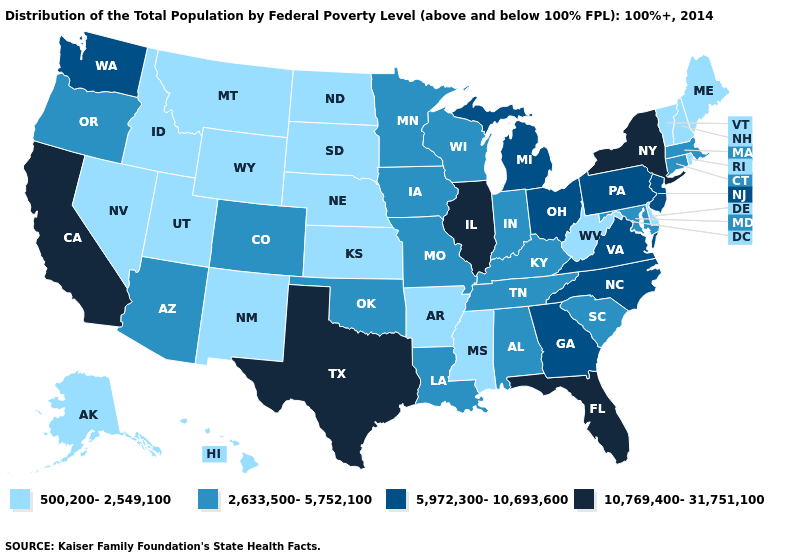How many symbols are there in the legend?
Give a very brief answer. 4. How many symbols are there in the legend?
Be succinct. 4. What is the value of Kansas?
Quick response, please. 500,200-2,549,100. What is the highest value in states that border Louisiana?
Concise answer only. 10,769,400-31,751,100. Which states hav the highest value in the West?
Answer briefly. California. Which states hav the highest value in the MidWest?
Be succinct. Illinois. What is the value of South Dakota?
Keep it brief. 500,200-2,549,100. Name the states that have a value in the range 10,769,400-31,751,100?
Write a very short answer. California, Florida, Illinois, New York, Texas. Does New Mexico have the lowest value in the USA?
Keep it brief. Yes. Does Nevada have the highest value in the West?
Quick response, please. No. What is the lowest value in states that border Nebraska?
Be succinct. 500,200-2,549,100. Which states have the highest value in the USA?
Quick response, please. California, Florida, Illinois, New York, Texas. Does Hawaii have a lower value than New Mexico?
Answer briefly. No. Which states have the lowest value in the West?
Be succinct. Alaska, Hawaii, Idaho, Montana, Nevada, New Mexico, Utah, Wyoming. What is the value of New Mexico?
Answer briefly. 500,200-2,549,100. 